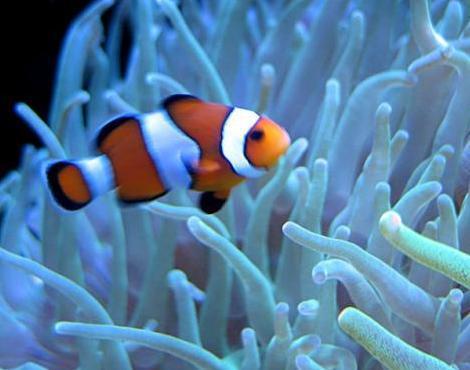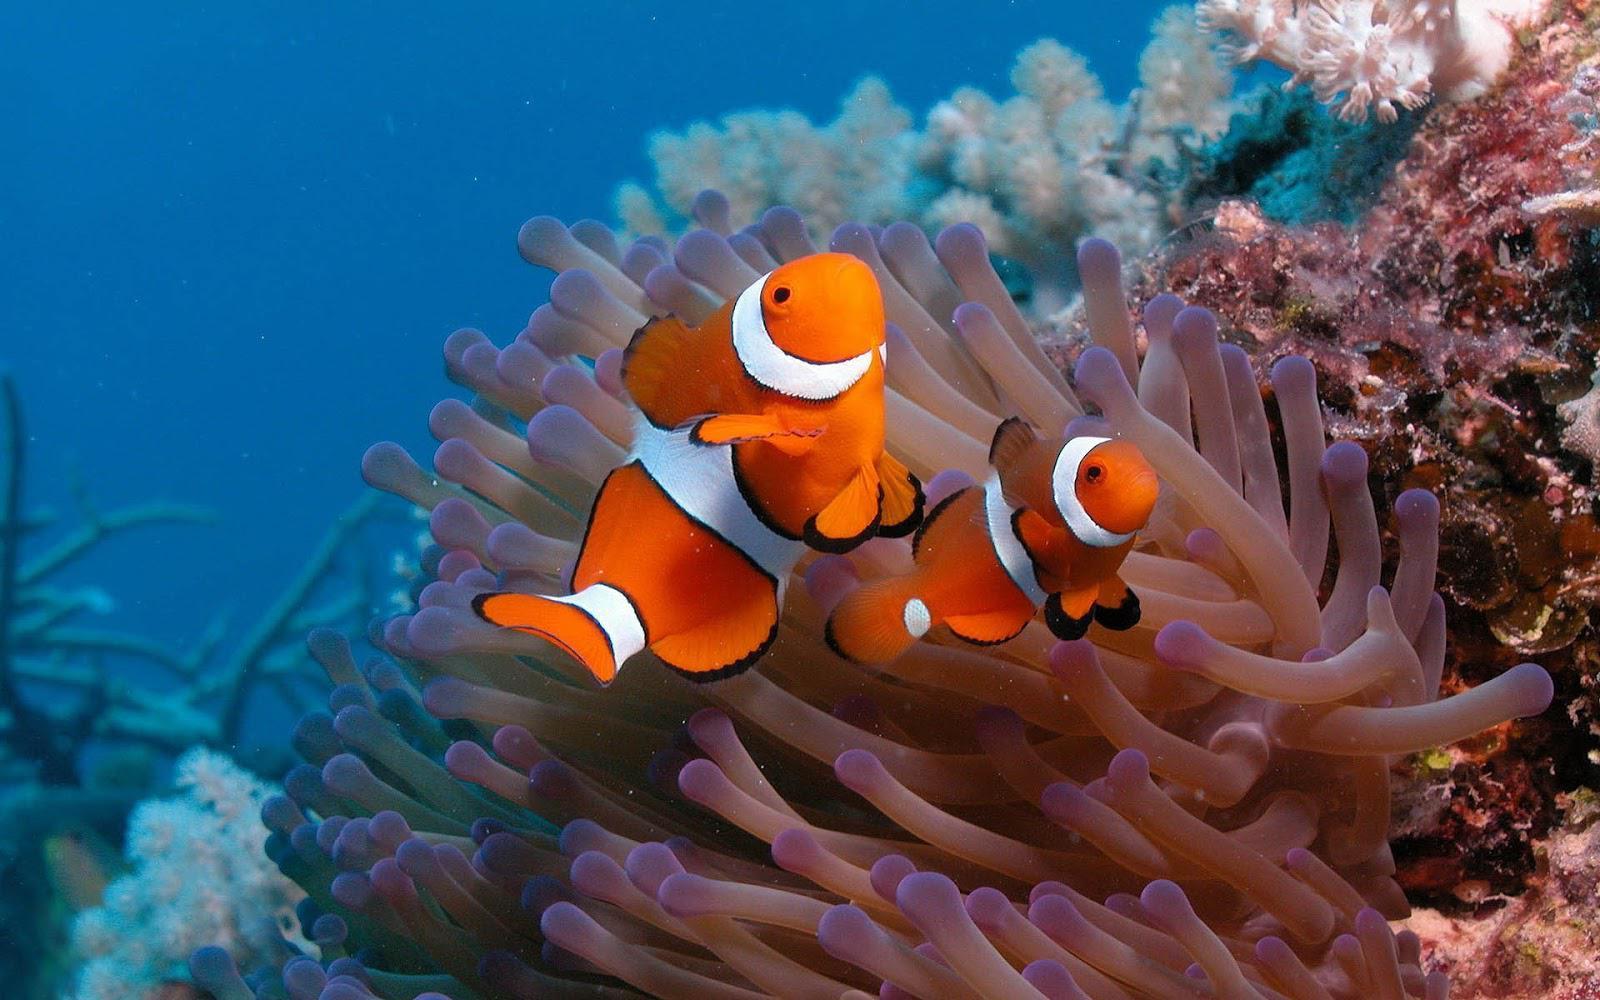The first image is the image on the left, the second image is the image on the right. Evaluate the accuracy of this statement regarding the images: "there is one clownfish facing right on the right image". Is it true? Answer yes or no. Yes. 